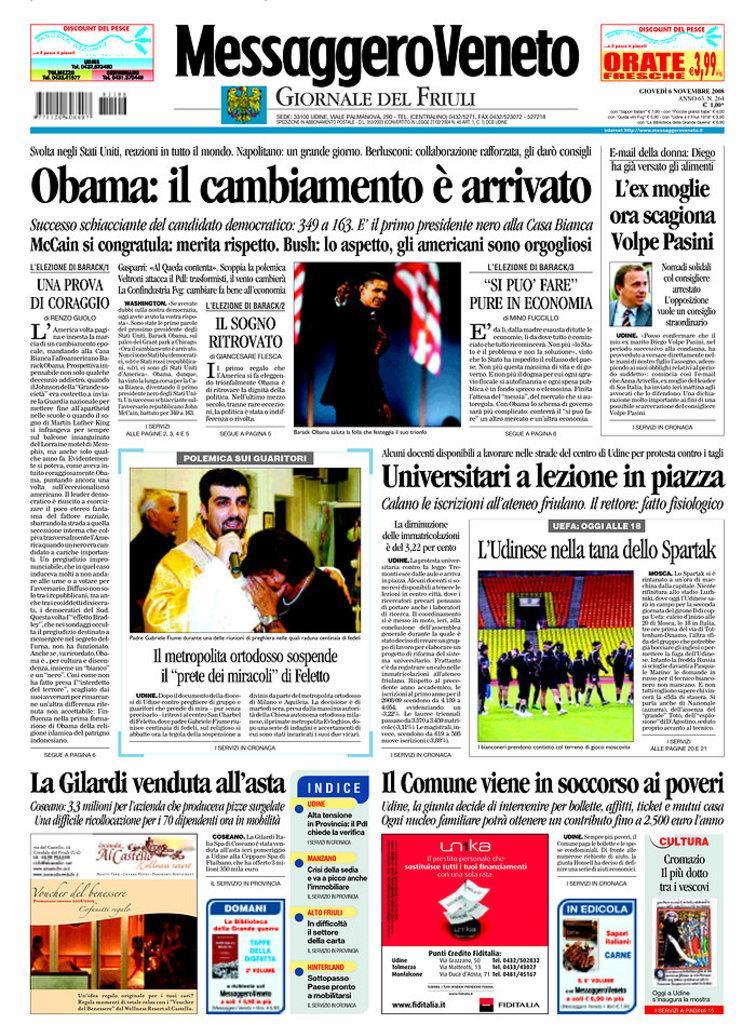Please provide a concise description of this image. Picture of a newspaper. Something written on this newspaper. On this newspaper we can see pictures of people. Here we can see barcodes and logo. In this image there are flags. 